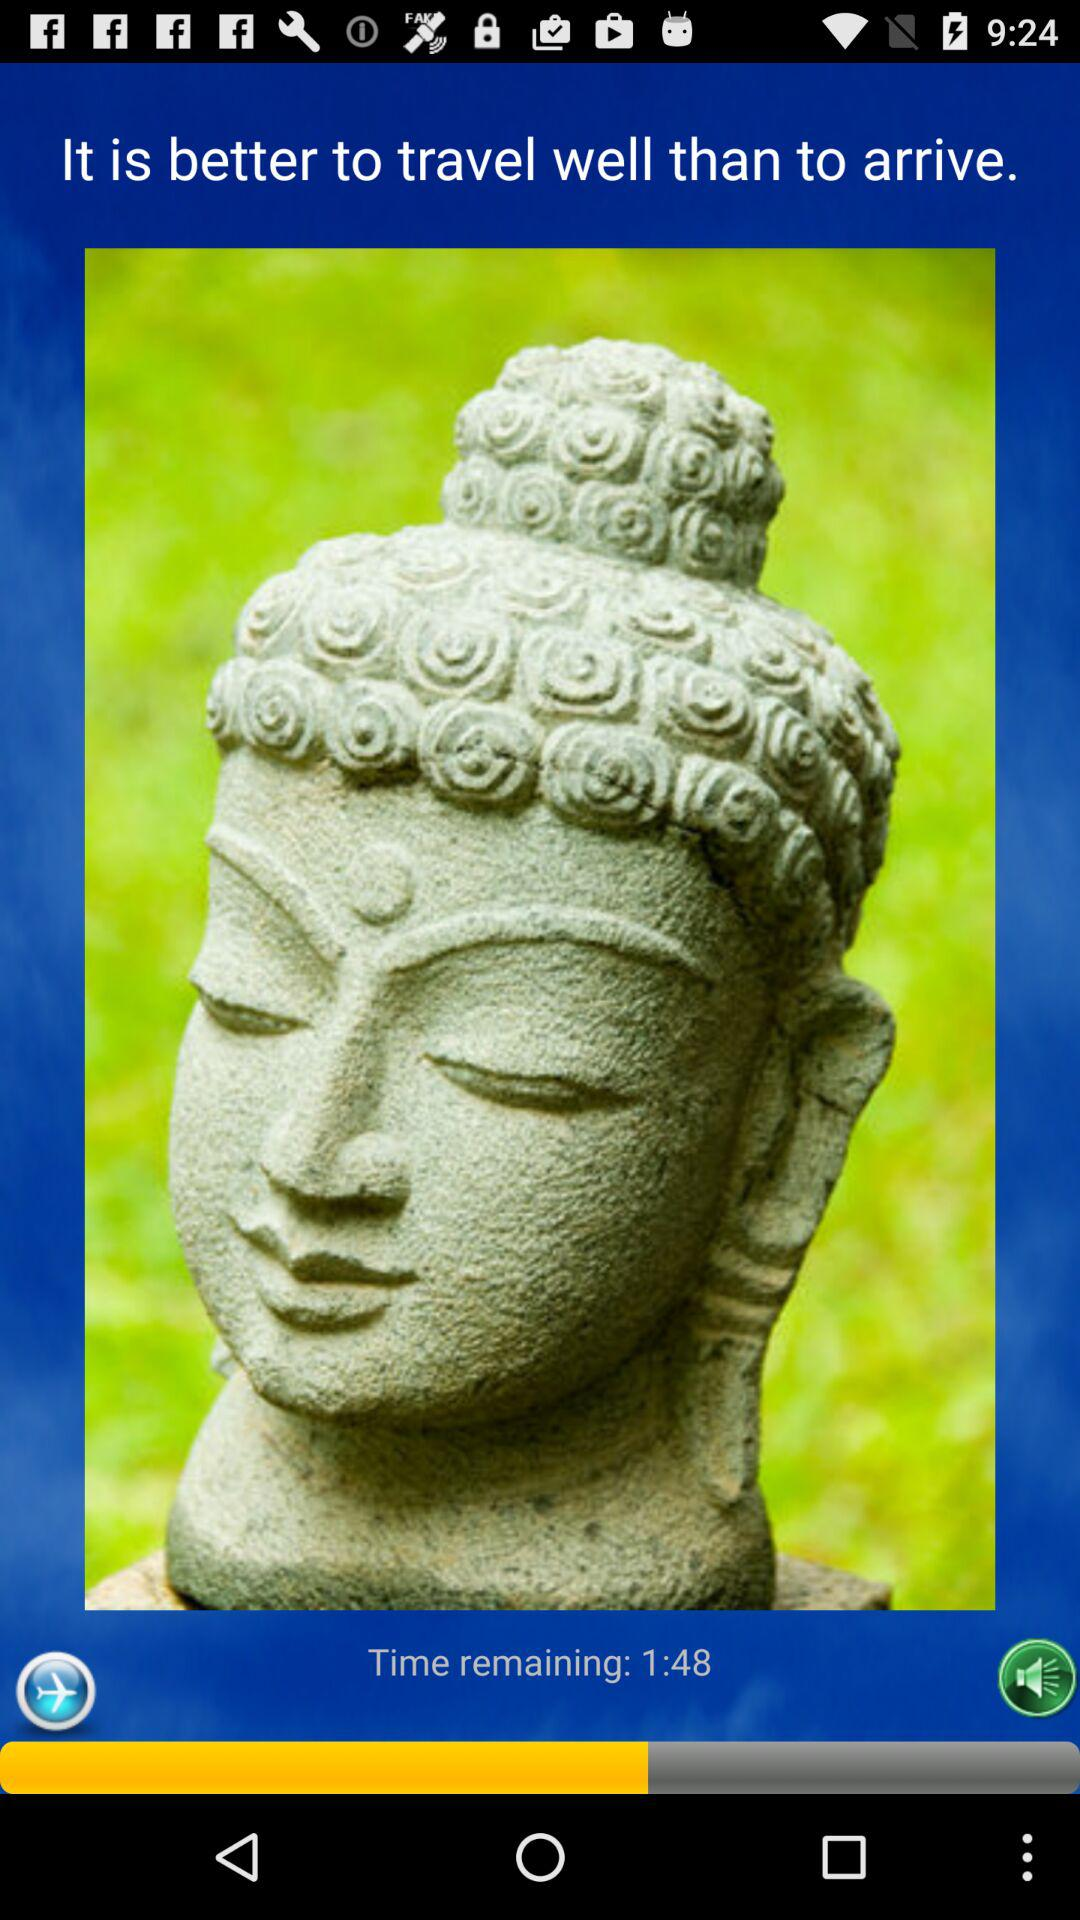How much time is remaining? The remaining time is 1 minute and 48 seconds. 